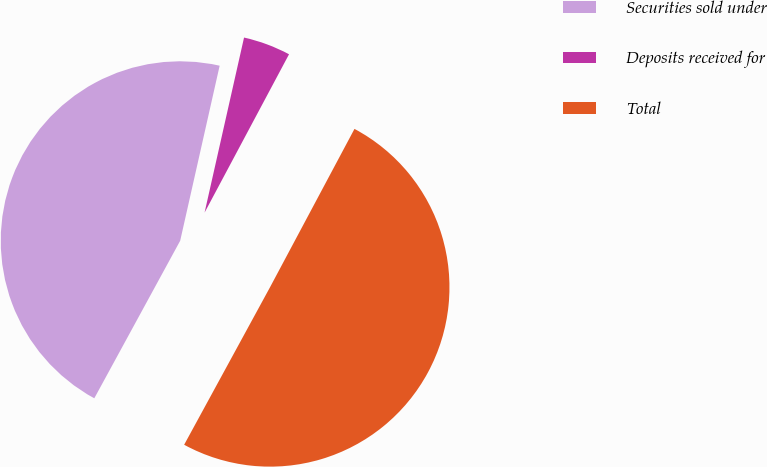<chart> <loc_0><loc_0><loc_500><loc_500><pie_chart><fcel>Securities sold under<fcel>Deposits received for<fcel>Total<nl><fcel>45.59%<fcel>4.27%<fcel>50.15%<nl></chart> 